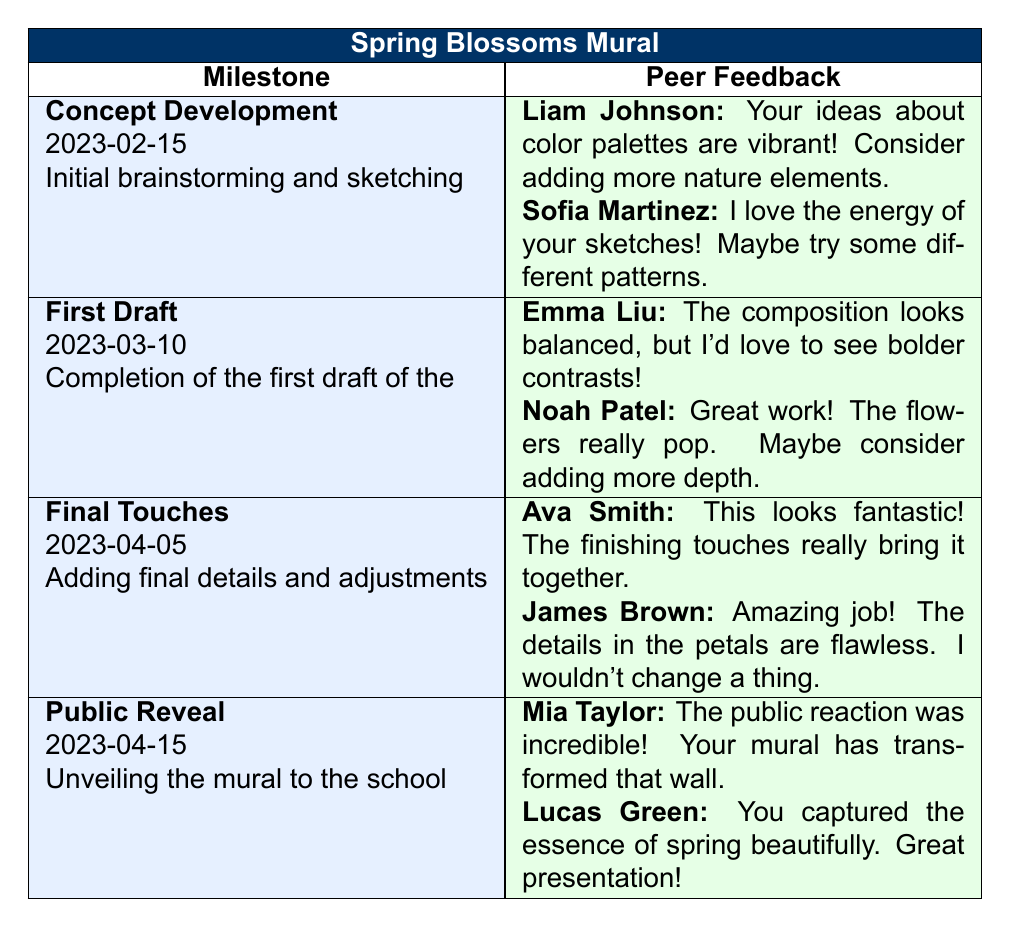What is the date of the "Final Touches" milestone? The table lists multiple milestones along with their corresponding dates. Looking at the row for "Final Touches," the date mentioned is 2023-04-05.
Answer: 2023-04-05 Who provided feedback on the "First Draft" milestone? The "First Draft" section shows two peer feedback comments. The comments are from Emma Liu and Noah Patel.
Answer: Emma Liu, Noah Patel Is there any feedback from Ava Smith on the "Concept Development" milestone? Ava Smith's comments are listed under the "Final Touches" milestone, while the "Concept Development" milestone contains comments only from Liam Johnson and Sofia Martinez. Thus, Ava Smith did not provide feedback for this milestone.
Answer: No Which milestone received the most positive feedback based on peer comments? Evaluating the feedback, "Final Touches" has very positive comments: Ava Smith mentioned it looks fantastic while James Brown said the details are flawless. Whereas other milestones had suggestions for improvement. So, "Final Touches" received the most positive feedback.
Answer: Final Touches What is the average number of feedback comments for each milestone? There are four milestones. The "Concept Development" has 2 comments, the "First Draft" has 2, the "Final Touches" has 2, and the "Public Reveal" has 2 as well. Adding them gives a total of 8 comments across 4 milestones, resulting in an average of 8/4 = 2 comments per milestone.
Answer: 2 Did any peer mention something specific about colors in their feedback? Yes, Liam Johnson commented on the vibrant color palettes in the "Concept Development" milestone, indicating a specific opinion on colors.
Answer: Yes How many peers provided feedback on the "Public Reveal" milestone? The "Public Reveal" milestone includes two comments from peers: Mia Taylor and Lucas Green. Therefore, two peers provided feedback on this milestone.
Answer: 2 What are the two suggestions made for improving the "First Draft"? The feedback for "First Draft" includes Emma Liu suggesting bolder contrasts and Noah Patel suggesting adding more depth. These are two suggestions from the peers for improving the draft.
Answer: Bolder contrasts, more depth 